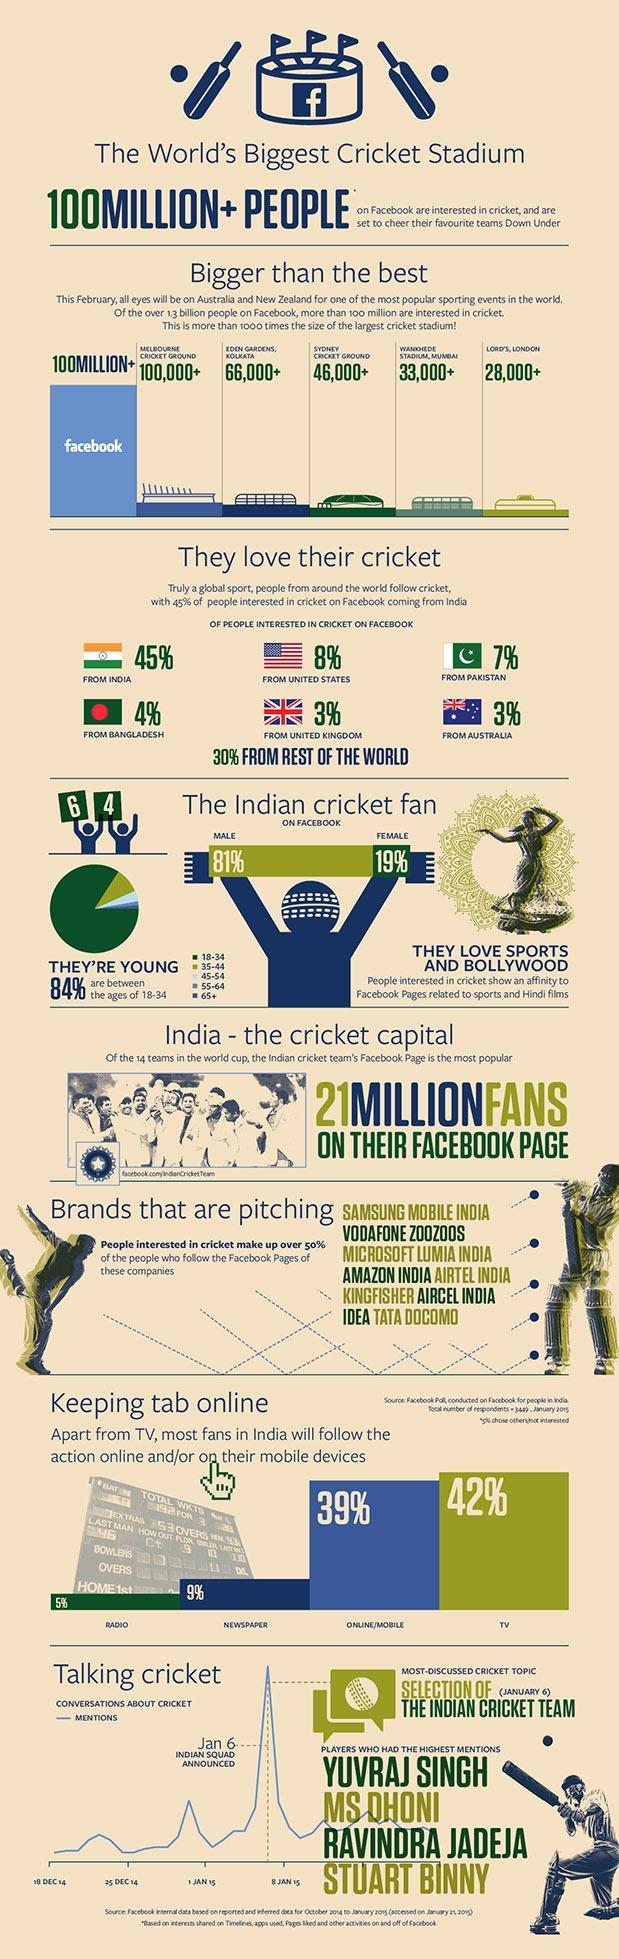Identify some key points in this picture. The capacity of Eden Gardens, Kolkata, is approximately 100,000, with the potential to accommodate more depending on the event. The stadium has a listed capacity of 66,000, but it can be expanded to hold up to 46,000 people. According to a recent study, only 3% of British and Aussie Facebook users follow cricket on the social media platform. Online and mobile platforms are the second most popular medium for cricket viewers to follow the sport. 